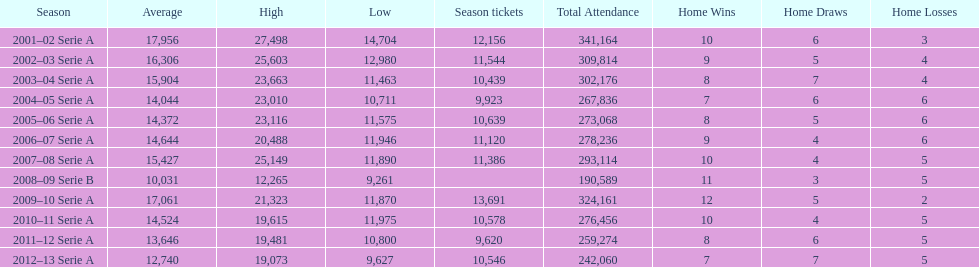What was the number of season tickets in 2007? 11,386. 